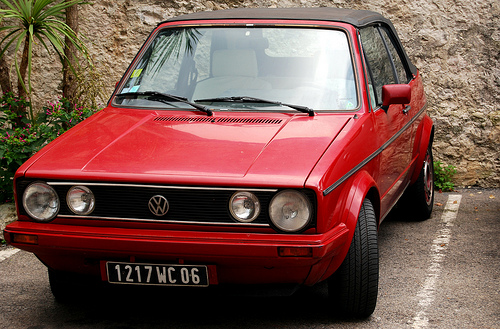<image>
Is the car in the road? Yes. The car is contained within or inside the road, showing a containment relationship. Is there a emblem in front of the hood? Yes. The emblem is positioned in front of the hood, appearing closer to the camera viewpoint. 